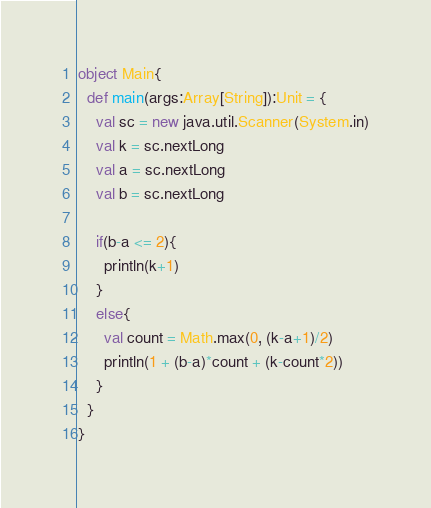<code> <loc_0><loc_0><loc_500><loc_500><_Scala_>object Main{
  def main(args:Array[String]):Unit = {
    val sc = new java.util.Scanner(System.in)
    val k = sc.nextLong
    val a = sc.nextLong
    val b = sc.nextLong
    
    if(b-a <= 2){
      println(k+1)
    }
    else{
      val count = Math.max(0, (k-a+1)/2)
      println(1 + (b-a)*count + (k-count*2))
    }
  }
}
</code> 